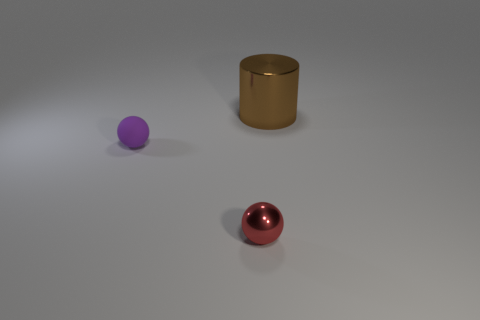How big is the metal thing behind the metal object in front of the object that is behind the purple sphere? The size of the metal cylinder behind the front metal sphere and in front of the purple sphere appears to be relatively large compared to the objects in the foreground. It is difficult to provide a precise measurement without additional context or reference points for scale, but it seems to have a greater volume than the other visible objects. 